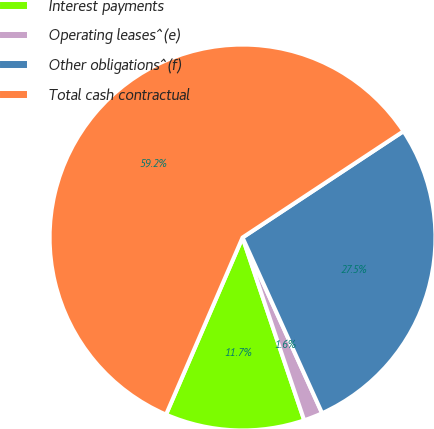<chart> <loc_0><loc_0><loc_500><loc_500><pie_chart><fcel>Interest payments<fcel>Operating leases^(e)<fcel>Other obligations^(f)<fcel>Total cash contractual<nl><fcel>11.67%<fcel>1.59%<fcel>27.52%<fcel>59.22%<nl></chart> 